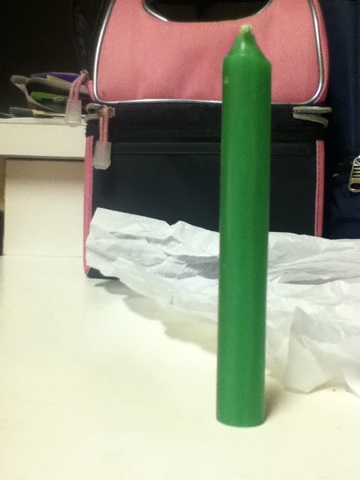Where might this type of candle be used? This type of tall, slender green candle is commonly used in settings that require a long burn time, such as during dinner parties, at religious ceremonies, or for decorative purposes in places seeking a tranquil or meditative atmosphere. 